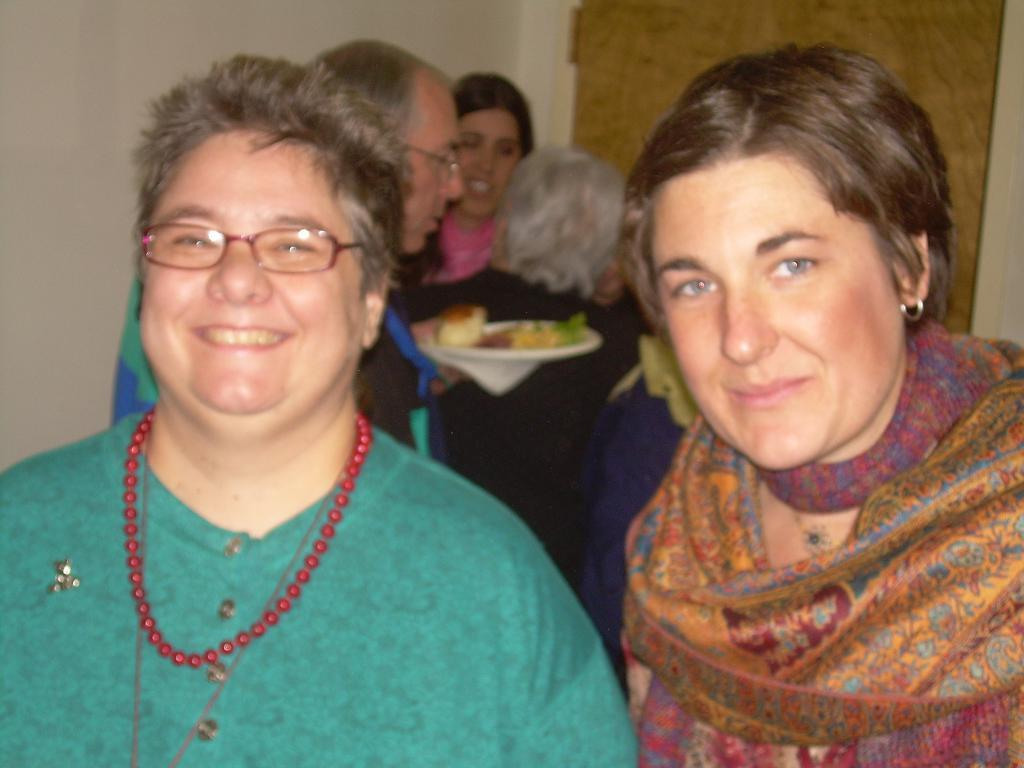How many people are in the image? There are people in the image. Can you describe the expressions of the people in the image? Two people are smiling. What is one person holding in the image? One person is holding a plate with food. What can be seen in the background of the image? There is a wall and a door in the background of the image. What type of fact can be seen floating in the air in the image? There is no fact visible in the image, as facts are not physical objects that can be seen. 